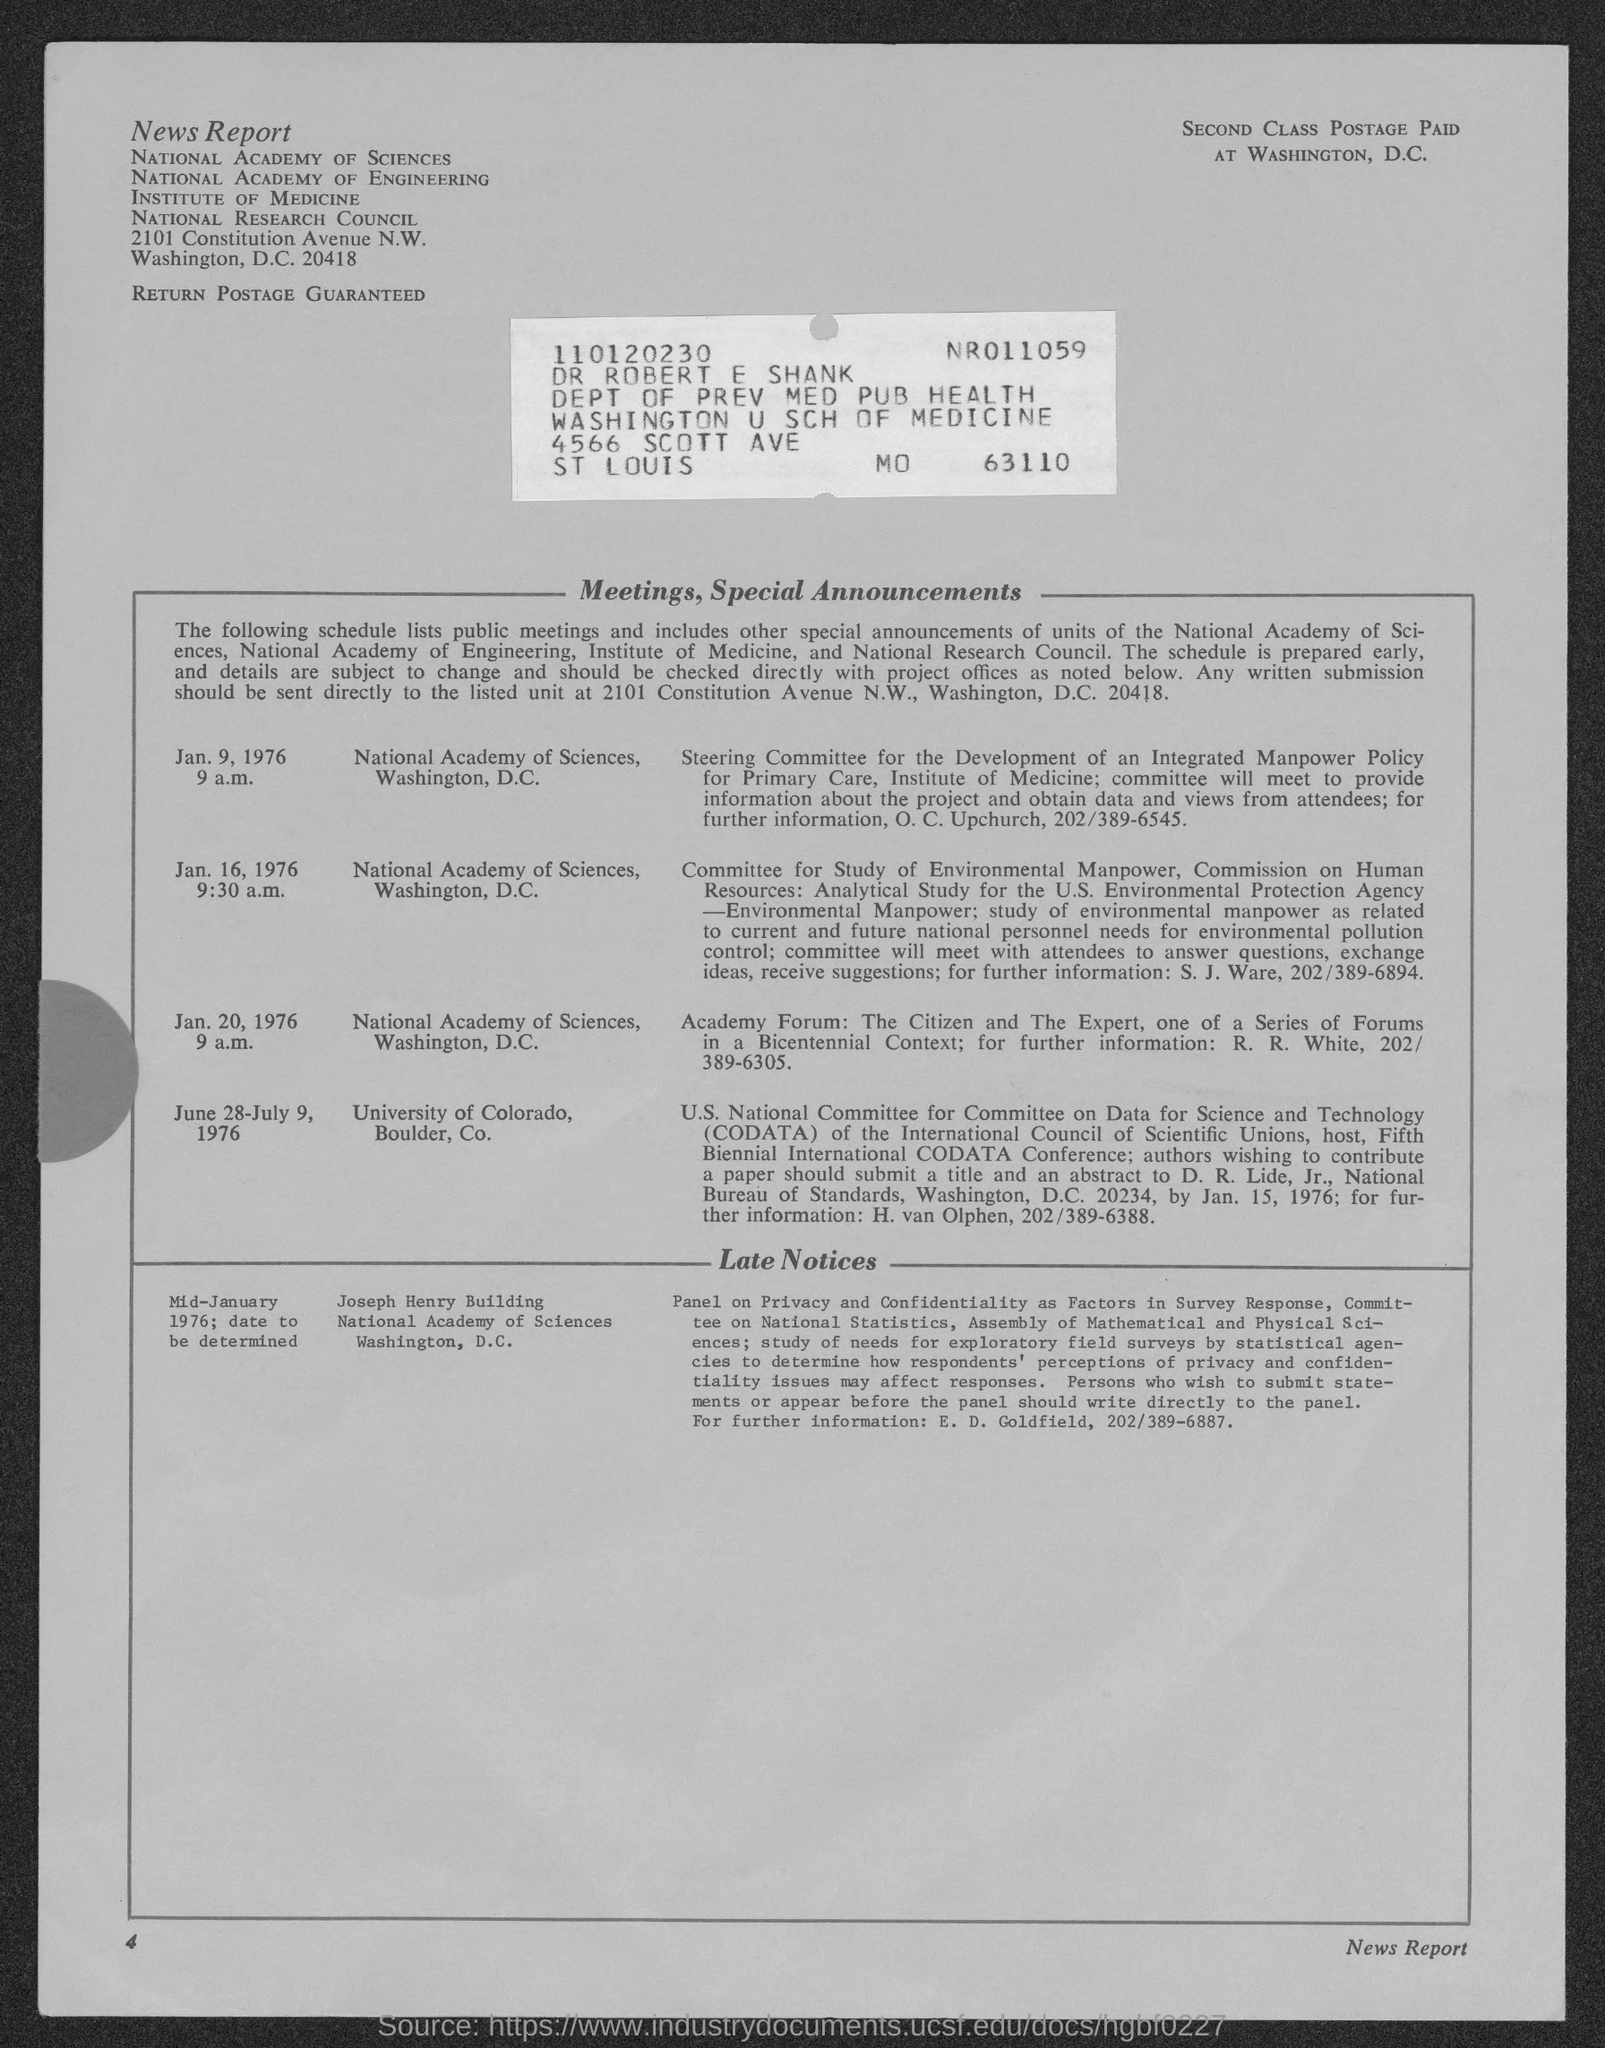Point out several critical features in this image. What time is the meeting on January 9, 1976? 9:00 a.m. The meeting is scheduled for 9:30 a.m. on January 16, 1976. Dr. Robert E. Shank belongs to the Department of Preventive Medicine and Public Health. The page number given at the left bottom corner of the page is 4. The meeting was scheduled for 9 a.m. on Jan. 20, 1976. 